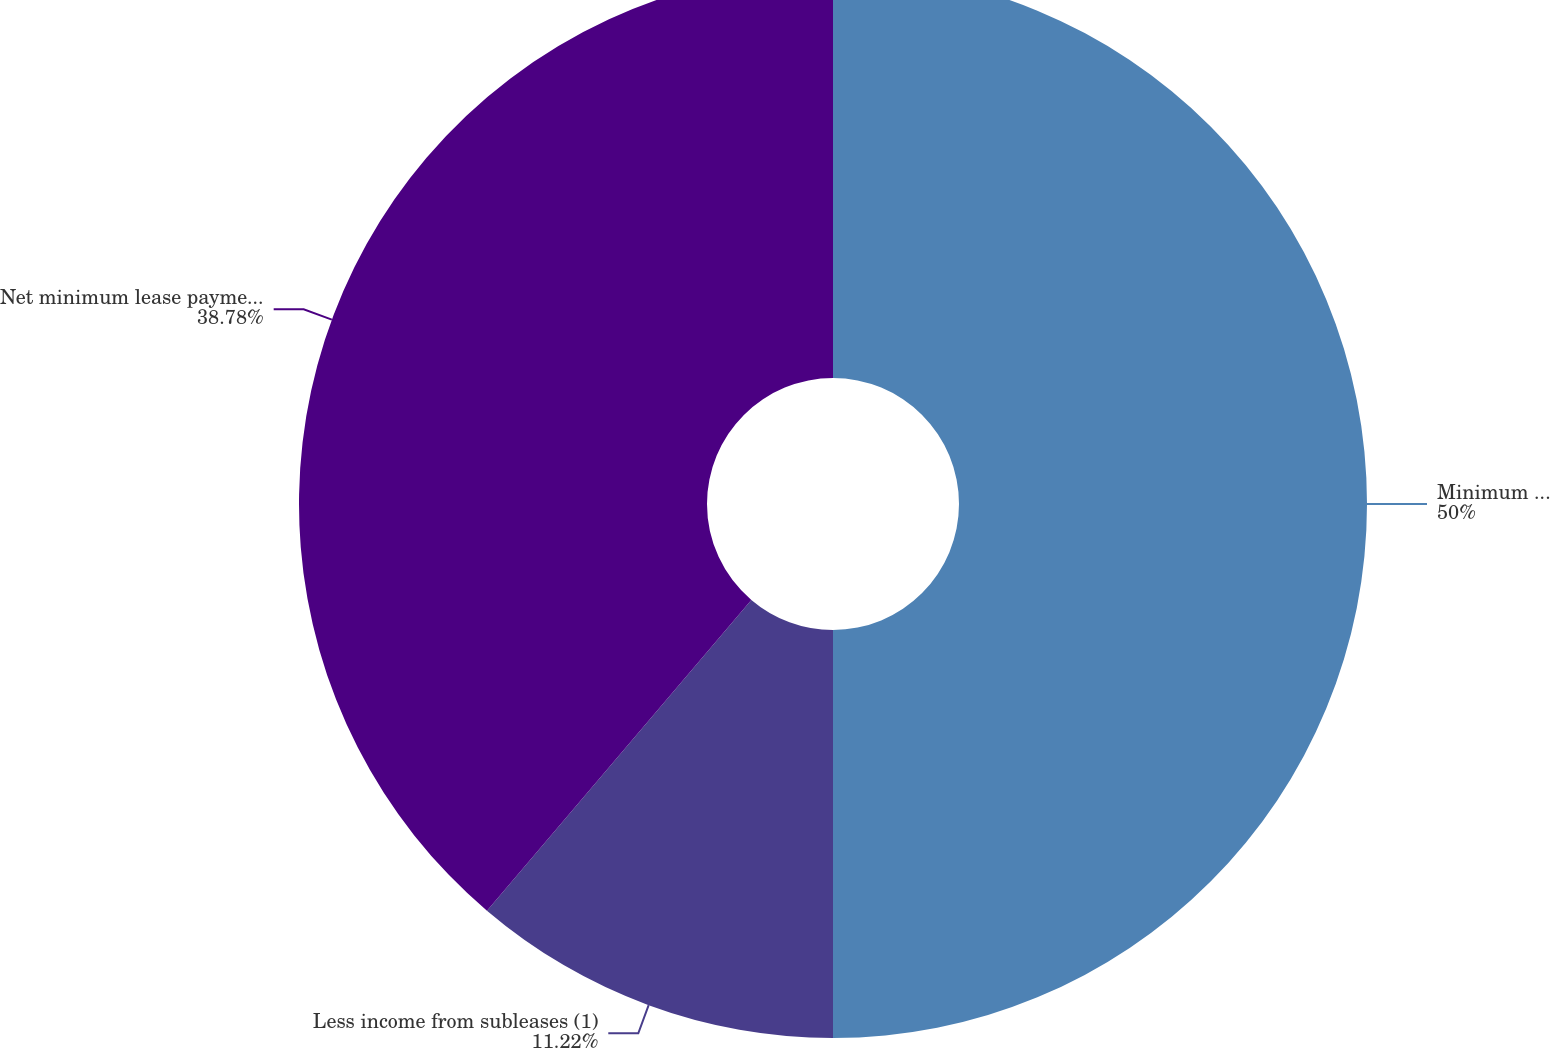Convert chart. <chart><loc_0><loc_0><loc_500><loc_500><pie_chart><fcel>Minimum lease payments<fcel>Less income from subleases (1)<fcel>Net minimum lease payments<nl><fcel>50.0%<fcel>11.22%<fcel>38.78%<nl></chart> 